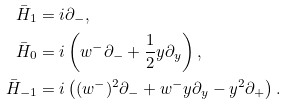Convert formula to latex. <formula><loc_0><loc_0><loc_500><loc_500>\bar { H } _ { 1 } & = i \partial _ { - } , \\ \bar { H } _ { 0 } & = i \left ( w ^ { - } \partial _ { - } + \frac { 1 } { 2 } y \partial _ { y } \right ) , \\ \bar { H } _ { - 1 } & = i \left ( ( w ^ { - } ) ^ { 2 } \partial _ { - } + w ^ { - } y \partial _ { y } - y ^ { 2 } \partial _ { + } \right ) .</formula> 